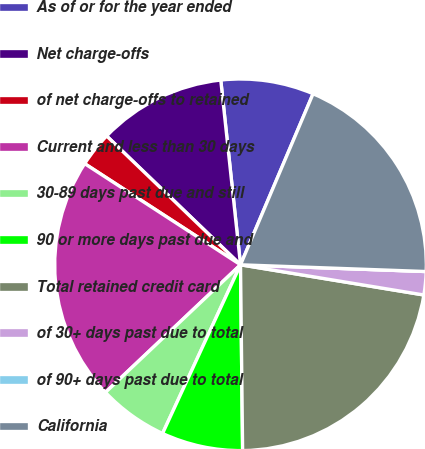<chart> <loc_0><loc_0><loc_500><loc_500><pie_chart><fcel>As of or for the year ended<fcel>Net charge-offs<fcel>of net charge-offs to retained<fcel>Current and less than 30 days<fcel>30-89 days past due and still<fcel>90 or more days past due and<fcel>Total retained credit card<fcel>of 30+ days past due to total<fcel>of 90+ days past due to total<fcel>California<nl><fcel>8.08%<fcel>11.11%<fcel>3.03%<fcel>21.21%<fcel>6.06%<fcel>7.07%<fcel>22.22%<fcel>2.02%<fcel>0.0%<fcel>19.19%<nl></chart> 